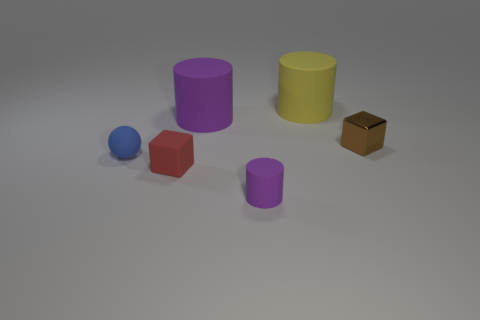Add 1 red matte cubes. How many objects exist? 7 Subtract all blocks. How many objects are left? 4 Add 2 blue metallic things. How many blue metallic things exist? 2 Subtract 1 blue balls. How many objects are left? 5 Subtract all rubber spheres. Subtract all tiny red objects. How many objects are left? 4 Add 2 small rubber blocks. How many small rubber blocks are left? 3 